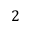Convert formula to latex. <formula><loc_0><loc_0><loc_500><loc_500>2</formula> 